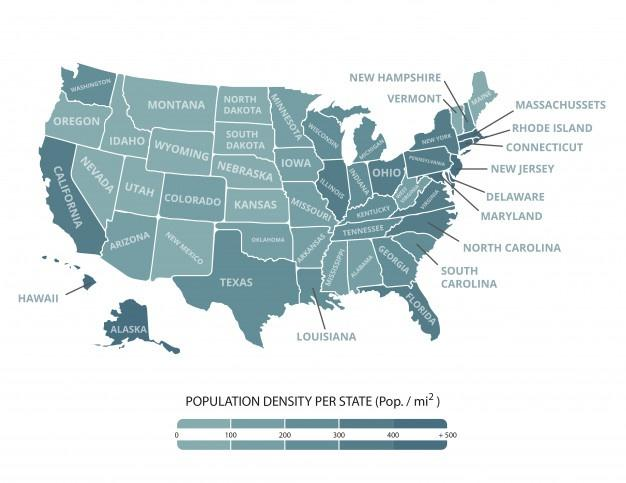Mention a couple of crucial points in this snapshot. The infographic mentions five groups of population density. 